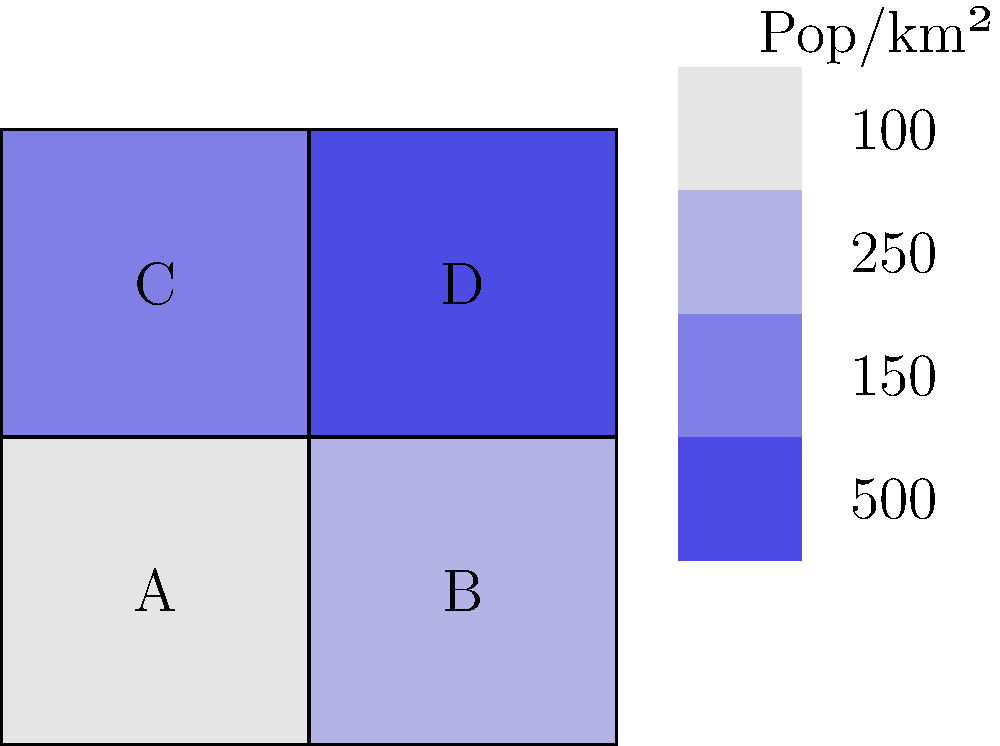The choropleth map shows the population density (people per square kilometer) of four districts in a state. If each district has an equal area of 2,500 km², what is the total population difference between the most and least populous districts? To solve this problem, we need to follow these steps:

1. Identify the most and least populous districts:
   - District A: 100 people/km²
   - District B: 250 people/km²
   - District C: 150 people/km²
   - District D: 500 people/km²
   
   The most populous is District D, and the least populous is District A.

2. Calculate the population of each district:
   - Area of each district = 2,500 km²
   - Population = Density × Area
   
   For District D (most populous):
   $Population_D = 500 \text{ people/km²} \times 2,500 \text{ km²} = 1,250,000 \text{ people}$
   
   For District A (least populous):
   $Population_A = 100 \text{ people/km²} \times 2,500 \text{ km²} = 250,000 \text{ people}$

3. Calculate the difference between the most and least populous districts:
   $Difference = Population_D - Population_A$
   $= 1,250,000 - 250,000 = 1,000,000 \text{ people}$

Therefore, the total population difference between the most and least populous districts is 1,000,000 people.
Answer: 1,000,000 people 